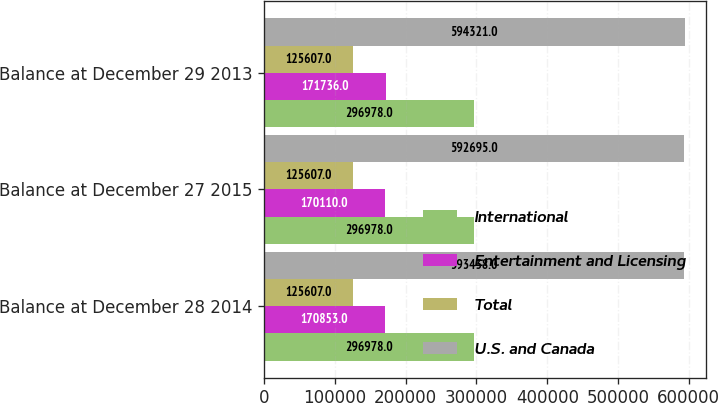<chart> <loc_0><loc_0><loc_500><loc_500><stacked_bar_chart><ecel><fcel>Balance at December 28 2014<fcel>Balance at December 27 2015<fcel>Balance at December 29 2013<nl><fcel>International<fcel>296978<fcel>296978<fcel>296978<nl><fcel>Entertainment and Licensing<fcel>170853<fcel>170110<fcel>171736<nl><fcel>Total<fcel>125607<fcel>125607<fcel>125607<nl><fcel>U.S. and Canada<fcel>593438<fcel>592695<fcel>594321<nl></chart> 